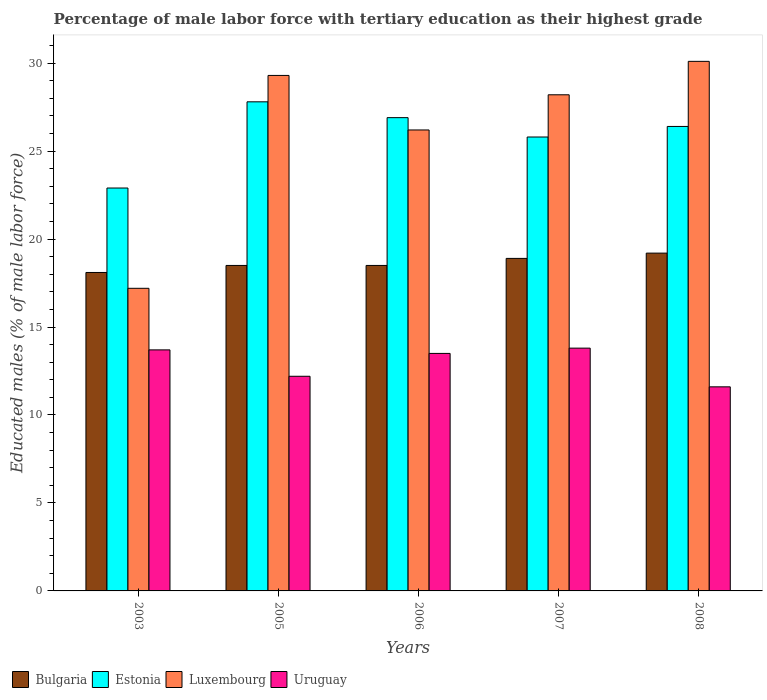How many different coloured bars are there?
Your response must be concise. 4. How many groups of bars are there?
Keep it short and to the point. 5. Are the number of bars on each tick of the X-axis equal?
Your answer should be compact. Yes. How many bars are there on the 5th tick from the left?
Keep it short and to the point. 4. How many bars are there on the 1st tick from the right?
Make the answer very short. 4. What is the label of the 5th group of bars from the left?
Offer a very short reply. 2008. What is the percentage of male labor force with tertiary education in Luxembourg in 2005?
Your answer should be very brief. 29.3. Across all years, what is the maximum percentage of male labor force with tertiary education in Uruguay?
Make the answer very short. 13.8. Across all years, what is the minimum percentage of male labor force with tertiary education in Bulgaria?
Your answer should be very brief. 18.1. In which year was the percentage of male labor force with tertiary education in Uruguay maximum?
Offer a very short reply. 2007. What is the total percentage of male labor force with tertiary education in Bulgaria in the graph?
Your answer should be compact. 93.2. What is the difference between the percentage of male labor force with tertiary education in Luxembourg in 2003 and that in 2006?
Ensure brevity in your answer.  -9. What is the difference between the percentage of male labor force with tertiary education in Uruguay in 2008 and the percentage of male labor force with tertiary education in Estonia in 2003?
Provide a succinct answer. -11.3. What is the average percentage of male labor force with tertiary education in Luxembourg per year?
Offer a very short reply. 26.2. In the year 2003, what is the difference between the percentage of male labor force with tertiary education in Luxembourg and percentage of male labor force with tertiary education in Bulgaria?
Give a very brief answer. -0.9. What is the ratio of the percentage of male labor force with tertiary education in Luxembourg in 2003 to that in 2007?
Your answer should be compact. 0.61. What is the difference between the highest and the second highest percentage of male labor force with tertiary education in Luxembourg?
Your response must be concise. 0.8. What is the difference between the highest and the lowest percentage of male labor force with tertiary education in Estonia?
Provide a short and direct response. 4.9. In how many years, is the percentage of male labor force with tertiary education in Estonia greater than the average percentage of male labor force with tertiary education in Estonia taken over all years?
Provide a succinct answer. 3. Is it the case that in every year, the sum of the percentage of male labor force with tertiary education in Estonia and percentage of male labor force with tertiary education in Bulgaria is greater than the sum of percentage of male labor force with tertiary education in Luxembourg and percentage of male labor force with tertiary education in Uruguay?
Your answer should be compact. Yes. What does the 4th bar from the left in 2003 represents?
Ensure brevity in your answer.  Uruguay. Is it the case that in every year, the sum of the percentage of male labor force with tertiary education in Luxembourg and percentage of male labor force with tertiary education in Bulgaria is greater than the percentage of male labor force with tertiary education in Uruguay?
Your response must be concise. Yes. Does the graph contain grids?
Your answer should be very brief. No. Where does the legend appear in the graph?
Ensure brevity in your answer.  Bottom left. How many legend labels are there?
Give a very brief answer. 4. How are the legend labels stacked?
Your response must be concise. Horizontal. What is the title of the graph?
Make the answer very short. Percentage of male labor force with tertiary education as their highest grade. Does "Malta" appear as one of the legend labels in the graph?
Provide a short and direct response. No. What is the label or title of the X-axis?
Offer a very short reply. Years. What is the label or title of the Y-axis?
Your response must be concise. Educated males (% of male labor force). What is the Educated males (% of male labor force) of Bulgaria in 2003?
Your answer should be compact. 18.1. What is the Educated males (% of male labor force) in Estonia in 2003?
Provide a succinct answer. 22.9. What is the Educated males (% of male labor force) in Luxembourg in 2003?
Offer a very short reply. 17.2. What is the Educated males (% of male labor force) of Uruguay in 2003?
Your answer should be very brief. 13.7. What is the Educated males (% of male labor force) in Estonia in 2005?
Offer a very short reply. 27.8. What is the Educated males (% of male labor force) in Luxembourg in 2005?
Give a very brief answer. 29.3. What is the Educated males (% of male labor force) of Uruguay in 2005?
Give a very brief answer. 12.2. What is the Educated males (% of male labor force) of Bulgaria in 2006?
Your answer should be very brief. 18.5. What is the Educated males (% of male labor force) in Estonia in 2006?
Offer a very short reply. 26.9. What is the Educated males (% of male labor force) of Luxembourg in 2006?
Offer a terse response. 26.2. What is the Educated males (% of male labor force) in Uruguay in 2006?
Offer a terse response. 13.5. What is the Educated males (% of male labor force) of Bulgaria in 2007?
Offer a terse response. 18.9. What is the Educated males (% of male labor force) in Estonia in 2007?
Provide a short and direct response. 25.8. What is the Educated males (% of male labor force) in Luxembourg in 2007?
Provide a short and direct response. 28.2. What is the Educated males (% of male labor force) in Uruguay in 2007?
Make the answer very short. 13.8. What is the Educated males (% of male labor force) in Bulgaria in 2008?
Provide a short and direct response. 19.2. What is the Educated males (% of male labor force) of Estonia in 2008?
Your answer should be very brief. 26.4. What is the Educated males (% of male labor force) in Luxembourg in 2008?
Your response must be concise. 30.1. What is the Educated males (% of male labor force) in Uruguay in 2008?
Provide a succinct answer. 11.6. Across all years, what is the maximum Educated males (% of male labor force) of Bulgaria?
Offer a terse response. 19.2. Across all years, what is the maximum Educated males (% of male labor force) of Estonia?
Your answer should be very brief. 27.8. Across all years, what is the maximum Educated males (% of male labor force) of Luxembourg?
Ensure brevity in your answer.  30.1. Across all years, what is the maximum Educated males (% of male labor force) of Uruguay?
Offer a very short reply. 13.8. Across all years, what is the minimum Educated males (% of male labor force) in Bulgaria?
Offer a very short reply. 18.1. Across all years, what is the minimum Educated males (% of male labor force) in Estonia?
Give a very brief answer. 22.9. Across all years, what is the minimum Educated males (% of male labor force) in Luxembourg?
Offer a very short reply. 17.2. Across all years, what is the minimum Educated males (% of male labor force) in Uruguay?
Make the answer very short. 11.6. What is the total Educated males (% of male labor force) of Bulgaria in the graph?
Give a very brief answer. 93.2. What is the total Educated males (% of male labor force) in Estonia in the graph?
Make the answer very short. 129.8. What is the total Educated males (% of male labor force) in Luxembourg in the graph?
Give a very brief answer. 131. What is the total Educated males (% of male labor force) in Uruguay in the graph?
Keep it short and to the point. 64.8. What is the difference between the Educated males (% of male labor force) in Estonia in 2003 and that in 2005?
Give a very brief answer. -4.9. What is the difference between the Educated males (% of male labor force) in Uruguay in 2003 and that in 2005?
Provide a succinct answer. 1.5. What is the difference between the Educated males (% of male labor force) of Estonia in 2003 and that in 2006?
Your answer should be very brief. -4. What is the difference between the Educated males (% of male labor force) in Bulgaria in 2003 and that in 2007?
Give a very brief answer. -0.8. What is the difference between the Educated males (% of male labor force) of Estonia in 2003 and that in 2007?
Offer a very short reply. -2.9. What is the difference between the Educated males (% of male labor force) of Uruguay in 2003 and that in 2007?
Provide a short and direct response. -0.1. What is the difference between the Educated males (% of male labor force) of Bulgaria in 2003 and that in 2008?
Give a very brief answer. -1.1. What is the difference between the Educated males (% of male labor force) in Luxembourg in 2003 and that in 2008?
Offer a very short reply. -12.9. What is the difference between the Educated males (% of male labor force) of Uruguay in 2003 and that in 2008?
Offer a terse response. 2.1. What is the difference between the Educated males (% of male labor force) in Bulgaria in 2005 and that in 2006?
Ensure brevity in your answer.  0. What is the difference between the Educated males (% of male labor force) of Uruguay in 2005 and that in 2006?
Offer a terse response. -1.3. What is the difference between the Educated males (% of male labor force) in Bulgaria in 2005 and that in 2008?
Provide a short and direct response. -0.7. What is the difference between the Educated males (% of male labor force) in Bulgaria in 2006 and that in 2007?
Give a very brief answer. -0.4. What is the difference between the Educated males (% of male labor force) in Uruguay in 2006 and that in 2007?
Provide a succinct answer. -0.3. What is the difference between the Educated males (% of male labor force) in Estonia in 2006 and that in 2008?
Offer a very short reply. 0.5. What is the difference between the Educated males (% of male labor force) in Luxembourg in 2006 and that in 2008?
Offer a very short reply. -3.9. What is the difference between the Educated males (% of male labor force) in Bulgaria in 2007 and that in 2008?
Ensure brevity in your answer.  -0.3. What is the difference between the Educated males (% of male labor force) in Estonia in 2007 and that in 2008?
Your answer should be compact. -0.6. What is the difference between the Educated males (% of male labor force) in Uruguay in 2007 and that in 2008?
Keep it short and to the point. 2.2. What is the difference between the Educated males (% of male labor force) of Bulgaria in 2003 and the Educated males (% of male labor force) of Luxembourg in 2005?
Offer a terse response. -11.2. What is the difference between the Educated males (% of male labor force) of Bulgaria in 2003 and the Educated males (% of male labor force) of Uruguay in 2005?
Ensure brevity in your answer.  5.9. What is the difference between the Educated males (% of male labor force) in Bulgaria in 2003 and the Educated males (% of male labor force) in Luxembourg in 2006?
Offer a very short reply. -8.1. What is the difference between the Educated males (% of male labor force) of Estonia in 2003 and the Educated males (% of male labor force) of Luxembourg in 2006?
Offer a terse response. -3.3. What is the difference between the Educated males (% of male labor force) in Estonia in 2003 and the Educated males (% of male labor force) in Uruguay in 2006?
Provide a short and direct response. 9.4. What is the difference between the Educated males (% of male labor force) of Luxembourg in 2003 and the Educated males (% of male labor force) of Uruguay in 2006?
Give a very brief answer. 3.7. What is the difference between the Educated males (% of male labor force) in Bulgaria in 2003 and the Educated males (% of male labor force) in Uruguay in 2007?
Provide a short and direct response. 4.3. What is the difference between the Educated males (% of male labor force) of Estonia in 2003 and the Educated males (% of male labor force) of Luxembourg in 2007?
Provide a succinct answer. -5.3. What is the difference between the Educated males (% of male labor force) of Luxembourg in 2003 and the Educated males (% of male labor force) of Uruguay in 2007?
Offer a terse response. 3.4. What is the difference between the Educated males (% of male labor force) of Bulgaria in 2003 and the Educated males (% of male labor force) of Estonia in 2008?
Offer a very short reply. -8.3. What is the difference between the Educated males (% of male labor force) of Bulgaria in 2005 and the Educated males (% of male labor force) of Luxembourg in 2006?
Ensure brevity in your answer.  -7.7. What is the difference between the Educated males (% of male labor force) in Estonia in 2005 and the Educated males (% of male labor force) in Luxembourg in 2006?
Give a very brief answer. 1.6. What is the difference between the Educated males (% of male labor force) in Estonia in 2005 and the Educated males (% of male labor force) in Uruguay in 2006?
Your answer should be very brief. 14.3. What is the difference between the Educated males (% of male labor force) in Bulgaria in 2005 and the Educated males (% of male labor force) in Uruguay in 2007?
Your answer should be compact. 4.7. What is the difference between the Educated males (% of male labor force) in Estonia in 2005 and the Educated males (% of male labor force) in Uruguay in 2007?
Your response must be concise. 14. What is the difference between the Educated males (% of male labor force) of Luxembourg in 2005 and the Educated males (% of male labor force) of Uruguay in 2007?
Your answer should be compact. 15.5. What is the difference between the Educated males (% of male labor force) of Bulgaria in 2005 and the Educated males (% of male labor force) of Estonia in 2008?
Offer a very short reply. -7.9. What is the difference between the Educated males (% of male labor force) in Bulgaria in 2005 and the Educated males (% of male labor force) in Luxembourg in 2008?
Make the answer very short. -11.6. What is the difference between the Educated males (% of male labor force) in Bulgaria in 2005 and the Educated males (% of male labor force) in Uruguay in 2008?
Ensure brevity in your answer.  6.9. What is the difference between the Educated males (% of male labor force) of Estonia in 2005 and the Educated males (% of male labor force) of Luxembourg in 2008?
Give a very brief answer. -2.3. What is the difference between the Educated males (% of male labor force) in Estonia in 2005 and the Educated males (% of male labor force) in Uruguay in 2008?
Make the answer very short. 16.2. What is the difference between the Educated males (% of male labor force) in Bulgaria in 2006 and the Educated males (% of male labor force) in Estonia in 2007?
Your response must be concise. -7.3. What is the difference between the Educated males (% of male labor force) in Bulgaria in 2006 and the Educated males (% of male labor force) in Uruguay in 2007?
Ensure brevity in your answer.  4.7. What is the difference between the Educated males (% of male labor force) of Estonia in 2006 and the Educated males (% of male labor force) of Uruguay in 2007?
Your answer should be compact. 13.1. What is the difference between the Educated males (% of male labor force) in Luxembourg in 2006 and the Educated males (% of male labor force) in Uruguay in 2007?
Your response must be concise. 12.4. What is the difference between the Educated males (% of male labor force) in Bulgaria in 2006 and the Educated males (% of male labor force) in Luxembourg in 2008?
Ensure brevity in your answer.  -11.6. What is the difference between the Educated males (% of male labor force) of Estonia in 2006 and the Educated males (% of male labor force) of Luxembourg in 2008?
Ensure brevity in your answer.  -3.2. What is the difference between the Educated males (% of male labor force) in Bulgaria in 2007 and the Educated males (% of male labor force) in Luxembourg in 2008?
Your response must be concise. -11.2. What is the difference between the Educated males (% of male labor force) of Estonia in 2007 and the Educated males (% of male labor force) of Luxembourg in 2008?
Your answer should be compact. -4.3. What is the difference between the Educated males (% of male labor force) of Luxembourg in 2007 and the Educated males (% of male labor force) of Uruguay in 2008?
Provide a short and direct response. 16.6. What is the average Educated males (% of male labor force) of Bulgaria per year?
Ensure brevity in your answer.  18.64. What is the average Educated males (% of male labor force) in Estonia per year?
Your response must be concise. 25.96. What is the average Educated males (% of male labor force) of Luxembourg per year?
Your response must be concise. 26.2. What is the average Educated males (% of male labor force) in Uruguay per year?
Provide a succinct answer. 12.96. In the year 2003, what is the difference between the Educated males (% of male labor force) in Bulgaria and Educated males (% of male labor force) in Luxembourg?
Give a very brief answer. 0.9. In the year 2003, what is the difference between the Educated males (% of male labor force) in Estonia and Educated males (% of male labor force) in Uruguay?
Provide a short and direct response. 9.2. In the year 2003, what is the difference between the Educated males (% of male labor force) in Luxembourg and Educated males (% of male labor force) in Uruguay?
Provide a succinct answer. 3.5. In the year 2005, what is the difference between the Educated males (% of male labor force) of Bulgaria and Educated males (% of male labor force) of Estonia?
Your answer should be very brief. -9.3. In the year 2005, what is the difference between the Educated males (% of male labor force) in Bulgaria and Educated males (% of male labor force) in Luxembourg?
Your response must be concise. -10.8. In the year 2005, what is the difference between the Educated males (% of male labor force) of Bulgaria and Educated males (% of male labor force) of Uruguay?
Provide a short and direct response. 6.3. In the year 2005, what is the difference between the Educated males (% of male labor force) in Estonia and Educated males (% of male labor force) in Uruguay?
Your answer should be compact. 15.6. In the year 2006, what is the difference between the Educated males (% of male labor force) of Bulgaria and Educated males (% of male labor force) of Estonia?
Make the answer very short. -8.4. In the year 2006, what is the difference between the Educated males (% of male labor force) of Bulgaria and Educated males (% of male labor force) of Luxembourg?
Your answer should be very brief. -7.7. In the year 2006, what is the difference between the Educated males (% of male labor force) in Bulgaria and Educated males (% of male labor force) in Uruguay?
Your answer should be compact. 5. In the year 2006, what is the difference between the Educated males (% of male labor force) of Estonia and Educated males (% of male labor force) of Uruguay?
Keep it short and to the point. 13.4. In the year 2006, what is the difference between the Educated males (% of male labor force) of Luxembourg and Educated males (% of male labor force) of Uruguay?
Your answer should be compact. 12.7. In the year 2007, what is the difference between the Educated males (% of male labor force) of Bulgaria and Educated males (% of male labor force) of Estonia?
Your answer should be very brief. -6.9. In the year 2007, what is the difference between the Educated males (% of male labor force) in Estonia and Educated males (% of male labor force) in Luxembourg?
Keep it short and to the point. -2.4. In the year 2007, what is the difference between the Educated males (% of male labor force) in Luxembourg and Educated males (% of male labor force) in Uruguay?
Your answer should be compact. 14.4. In the year 2008, what is the difference between the Educated males (% of male labor force) of Estonia and Educated males (% of male labor force) of Uruguay?
Provide a short and direct response. 14.8. What is the ratio of the Educated males (% of male labor force) of Bulgaria in 2003 to that in 2005?
Make the answer very short. 0.98. What is the ratio of the Educated males (% of male labor force) of Estonia in 2003 to that in 2005?
Offer a terse response. 0.82. What is the ratio of the Educated males (% of male labor force) in Luxembourg in 2003 to that in 2005?
Offer a terse response. 0.59. What is the ratio of the Educated males (% of male labor force) of Uruguay in 2003 to that in 2005?
Keep it short and to the point. 1.12. What is the ratio of the Educated males (% of male labor force) of Bulgaria in 2003 to that in 2006?
Keep it short and to the point. 0.98. What is the ratio of the Educated males (% of male labor force) in Estonia in 2003 to that in 2006?
Your answer should be very brief. 0.85. What is the ratio of the Educated males (% of male labor force) in Luxembourg in 2003 to that in 2006?
Make the answer very short. 0.66. What is the ratio of the Educated males (% of male labor force) of Uruguay in 2003 to that in 2006?
Your response must be concise. 1.01. What is the ratio of the Educated males (% of male labor force) of Bulgaria in 2003 to that in 2007?
Provide a short and direct response. 0.96. What is the ratio of the Educated males (% of male labor force) of Estonia in 2003 to that in 2007?
Provide a succinct answer. 0.89. What is the ratio of the Educated males (% of male labor force) in Luxembourg in 2003 to that in 2007?
Provide a short and direct response. 0.61. What is the ratio of the Educated males (% of male labor force) in Uruguay in 2003 to that in 2007?
Provide a short and direct response. 0.99. What is the ratio of the Educated males (% of male labor force) of Bulgaria in 2003 to that in 2008?
Your response must be concise. 0.94. What is the ratio of the Educated males (% of male labor force) of Estonia in 2003 to that in 2008?
Make the answer very short. 0.87. What is the ratio of the Educated males (% of male labor force) of Uruguay in 2003 to that in 2008?
Your answer should be compact. 1.18. What is the ratio of the Educated males (% of male labor force) of Estonia in 2005 to that in 2006?
Your response must be concise. 1.03. What is the ratio of the Educated males (% of male labor force) of Luxembourg in 2005 to that in 2006?
Provide a succinct answer. 1.12. What is the ratio of the Educated males (% of male labor force) of Uruguay in 2005 to that in 2006?
Keep it short and to the point. 0.9. What is the ratio of the Educated males (% of male labor force) of Bulgaria in 2005 to that in 2007?
Your answer should be compact. 0.98. What is the ratio of the Educated males (% of male labor force) of Estonia in 2005 to that in 2007?
Your answer should be very brief. 1.08. What is the ratio of the Educated males (% of male labor force) of Luxembourg in 2005 to that in 2007?
Offer a terse response. 1.04. What is the ratio of the Educated males (% of male labor force) in Uruguay in 2005 to that in 2007?
Make the answer very short. 0.88. What is the ratio of the Educated males (% of male labor force) of Bulgaria in 2005 to that in 2008?
Provide a short and direct response. 0.96. What is the ratio of the Educated males (% of male labor force) in Estonia in 2005 to that in 2008?
Offer a very short reply. 1.05. What is the ratio of the Educated males (% of male labor force) of Luxembourg in 2005 to that in 2008?
Your answer should be compact. 0.97. What is the ratio of the Educated males (% of male labor force) in Uruguay in 2005 to that in 2008?
Keep it short and to the point. 1.05. What is the ratio of the Educated males (% of male labor force) of Bulgaria in 2006 to that in 2007?
Your answer should be compact. 0.98. What is the ratio of the Educated males (% of male labor force) of Estonia in 2006 to that in 2007?
Provide a short and direct response. 1.04. What is the ratio of the Educated males (% of male labor force) of Luxembourg in 2006 to that in 2007?
Provide a succinct answer. 0.93. What is the ratio of the Educated males (% of male labor force) of Uruguay in 2006 to that in 2007?
Make the answer very short. 0.98. What is the ratio of the Educated males (% of male labor force) in Bulgaria in 2006 to that in 2008?
Offer a terse response. 0.96. What is the ratio of the Educated males (% of male labor force) of Estonia in 2006 to that in 2008?
Your answer should be very brief. 1.02. What is the ratio of the Educated males (% of male labor force) in Luxembourg in 2006 to that in 2008?
Your answer should be compact. 0.87. What is the ratio of the Educated males (% of male labor force) in Uruguay in 2006 to that in 2008?
Provide a succinct answer. 1.16. What is the ratio of the Educated males (% of male labor force) of Bulgaria in 2007 to that in 2008?
Keep it short and to the point. 0.98. What is the ratio of the Educated males (% of male labor force) in Estonia in 2007 to that in 2008?
Make the answer very short. 0.98. What is the ratio of the Educated males (% of male labor force) of Luxembourg in 2007 to that in 2008?
Your answer should be compact. 0.94. What is the ratio of the Educated males (% of male labor force) in Uruguay in 2007 to that in 2008?
Give a very brief answer. 1.19. What is the difference between the highest and the second highest Educated males (% of male labor force) in Bulgaria?
Keep it short and to the point. 0.3. What is the difference between the highest and the second highest Educated males (% of male labor force) of Estonia?
Your answer should be very brief. 0.9. What is the difference between the highest and the lowest Educated males (% of male labor force) in Bulgaria?
Your answer should be compact. 1.1. What is the difference between the highest and the lowest Educated males (% of male labor force) in Estonia?
Provide a short and direct response. 4.9. What is the difference between the highest and the lowest Educated males (% of male labor force) of Luxembourg?
Your answer should be compact. 12.9. 